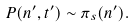Convert formula to latex. <formula><loc_0><loc_0><loc_500><loc_500>P ( n ^ { \prime } , t ^ { \prime } ) \sim \pi _ { s } ( n ^ { \prime } ) .</formula> 